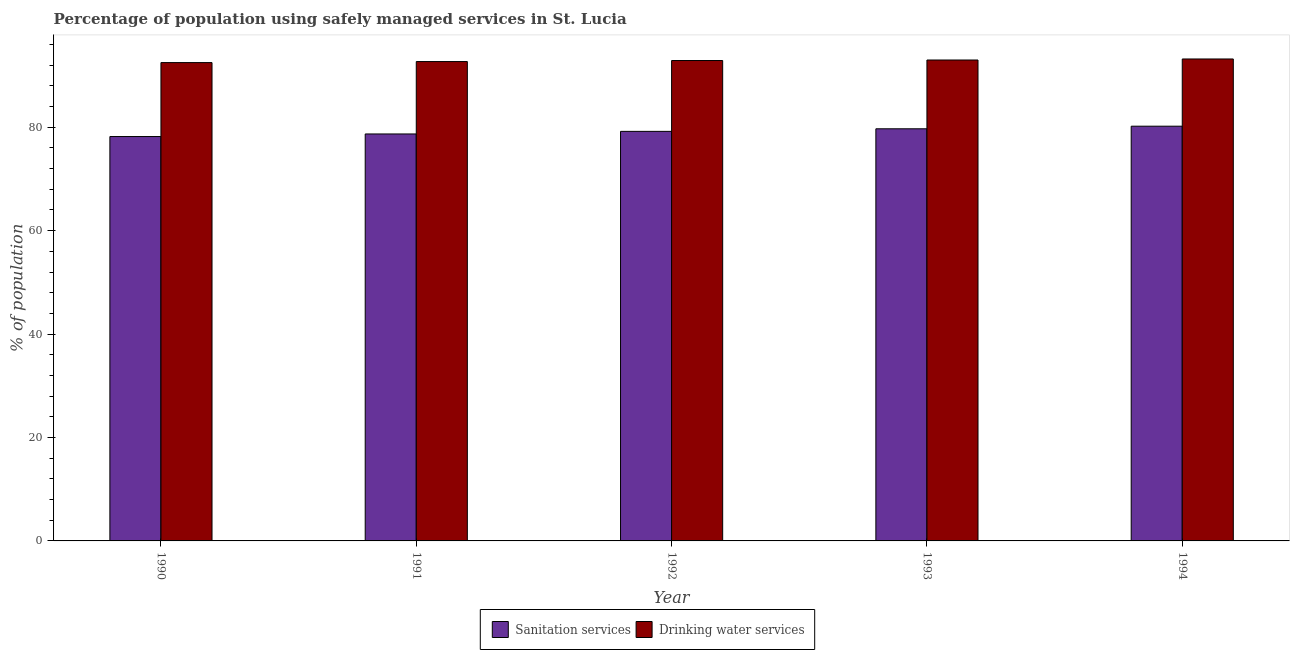Are the number of bars on each tick of the X-axis equal?
Your response must be concise. Yes. What is the label of the 1st group of bars from the left?
Offer a terse response. 1990. What is the percentage of population who used drinking water services in 1992?
Your answer should be very brief. 92.9. Across all years, what is the maximum percentage of population who used drinking water services?
Offer a terse response. 93.2. Across all years, what is the minimum percentage of population who used sanitation services?
Your answer should be very brief. 78.2. In which year was the percentage of population who used drinking water services maximum?
Give a very brief answer. 1994. In which year was the percentage of population who used drinking water services minimum?
Provide a short and direct response. 1990. What is the total percentage of population who used sanitation services in the graph?
Your answer should be very brief. 396. What is the difference between the percentage of population who used drinking water services in 1990 and that in 1994?
Offer a terse response. -0.7. What is the average percentage of population who used sanitation services per year?
Your answer should be very brief. 79.2. In how many years, is the percentage of population who used drinking water services greater than 52 %?
Your answer should be compact. 5. What is the ratio of the percentage of population who used drinking water services in 1990 to that in 1992?
Your answer should be very brief. 1. Is the percentage of population who used drinking water services in 1990 less than that in 1993?
Give a very brief answer. Yes. What is the difference between the highest and the second highest percentage of population who used drinking water services?
Provide a succinct answer. 0.2. What does the 2nd bar from the left in 1993 represents?
Your response must be concise. Drinking water services. What does the 2nd bar from the right in 1992 represents?
Your response must be concise. Sanitation services. Are all the bars in the graph horizontal?
Provide a short and direct response. No. How many years are there in the graph?
Offer a terse response. 5. What is the difference between two consecutive major ticks on the Y-axis?
Keep it short and to the point. 20. Where does the legend appear in the graph?
Ensure brevity in your answer.  Bottom center. How are the legend labels stacked?
Offer a very short reply. Horizontal. What is the title of the graph?
Your answer should be very brief. Percentage of population using safely managed services in St. Lucia. What is the label or title of the X-axis?
Provide a short and direct response. Year. What is the label or title of the Y-axis?
Make the answer very short. % of population. What is the % of population in Sanitation services in 1990?
Your response must be concise. 78.2. What is the % of population in Drinking water services in 1990?
Your answer should be compact. 92.5. What is the % of population in Sanitation services in 1991?
Provide a succinct answer. 78.7. What is the % of population of Drinking water services in 1991?
Offer a very short reply. 92.7. What is the % of population in Sanitation services in 1992?
Offer a terse response. 79.2. What is the % of population of Drinking water services in 1992?
Make the answer very short. 92.9. What is the % of population of Sanitation services in 1993?
Your answer should be very brief. 79.7. What is the % of population of Drinking water services in 1993?
Keep it short and to the point. 93. What is the % of population in Sanitation services in 1994?
Keep it short and to the point. 80.2. What is the % of population in Drinking water services in 1994?
Offer a terse response. 93.2. Across all years, what is the maximum % of population in Sanitation services?
Offer a very short reply. 80.2. Across all years, what is the maximum % of population in Drinking water services?
Your response must be concise. 93.2. Across all years, what is the minimum % of population of Sanitation services?
Provide a short and direct response. 78.2. Across all years, what is the minimum % of population in Drinking water services?
Provide a short and direct response. 92.5. What is the total % of population of Sanitation services in the graph?
Offer a terse response. 396. What is the total % of population in Drinking water services in the graph?
Keep it short and to the point. 464.3. What is the difference between the % of population of Drinking water services in 1990 and that in 1991?
Provide a short and direct response. -0.2. What is the difference between the % of population in Sanitation services in 1990 and that in 1992?
Your answer should be compact. -1. What is the difference between the % of population in Drinking water services in 1990 and that in 1993?
Your response must be concise. -0.5. What is the difference between the % of population in Sanitation services in 1990 and that in 1994?
Ensure brevity in your answer.  -2. What is the difference between the % of population in Drinking water services in 1991 and that in 1992?
Your answer should be very brief. -0.2. What is the difference between the % of population in Sanitation services in 1991 and that in 1993?
Your answer should be compact. -1. What is the difference between the % of population in Drinking water services in 1991 and that in 1994?
Keep it short and to the point. -0.5. What is the difference between the % of population of Sanitation services in 1992 and that in 1993?
Provide a short and direct response. -0.5. What is the difference between the % of population in Drinking water services in 1992 and that in 1993?
Provide a succinct answer. -0.1. What is the difference between the % of population in Drinking water services in 1992 and that in 1994?
Make the answer very short. -0.3. What is the difference between the % of population of Sanitation services in 1993 and that in 1994?
Your answer should be very brief. -0.5. What is the difference between the % of population in Sanitation services in 1990 and the % of population in Drinking water services in 1991?
Make the answer very short. -14.5. What is the difference between the % of population in Sanitation services in 1990 and the % of population in Drinking water services in 1992?
Your response must be concise. -14.7. What is the difference between the % of population in Sanitation services in 1990 and the % of population in Drinking water services in 1993?
Make the answer very short. -14.8. What is the difference between the % of population of Sanitation services in 1990 and the % of population of Drinking water services in 1994?
Provide a succinct answer. -15. What is the difference between the % of population in Sanitation services in 1991 and the % of population in Drinking water services in 1992?
Your response must be concise. -14.2. What is the difference between the % of population of Sanitation services in 1991 and the % of population of Drinking water services in 1993?
Make the answer very short. -14.3. What is the difference between the % of population in Sanitation services in 1992 and the % of population in Drinking water services in 1993?
Ensure brevity in your answer.  -13.8. What is the average % of population in Sanitation services per year?
Ensure brevity in your answer.  79.2. What is the average % of population in Drinking water services per year?
Your response must be concise. 92.86. In the year 1990, what is the difference between the % of population of Sanitation services and % of population of Drinking water services?
Ensure brevity in your answer.  -14.3. In the year 1991, what is the difference between the % of population in Sanitation services and % of population in Drinking water services?
Ensure brevity in your answer.  -14. In the year 1992, what is the difference between the % of population in Sanitation services and % of population in Drinking water services?
Offer a terse response. -13.7. In the year 1994, what is the difference between the % of population of Sanitation services and % of population of Drinking water services?
Keep it short and to the point. -13. What is the ratio of the % of population in Sanitation services in 1990 to that in 1992?
Provide a succinct answer. 0.99. What is the ratio of the % of population in Drinking water services in 1990 to that in 1992?
Your answer should be very brief. 1. What is the ratio of the % of population in Sanitation services in 1990 to that in 1993?
Offer a very short reply. 0.98. What is the ratio of the % of population of Drinking water services in 1990 to that in 1993?
Make the answer very short. 0.99. What is the ratio of the % of population of Sanitation services in 1990 to that in 1994?
Provide a succinct answer. 0.98. What is the ratio of the % of population in Drinking water services in 1990 to that in 1994?
Your answer should be very brief. 0.99. What is the ratio of the % of population of Drinking water services in 1991 to that in 1992?
Offer a very short reply. 1. What is the ratio of the % of population in Sanitation services in 1991 to that in 1993?
Provide a short and direct response. 0.99. What is the ratio of the % of population in Drinking water services in 1991 to that in 1993?
Your response must be concise. 1. What is the ratio of the % of population of Sanitation services in 1991 to that in 1994?
Ensure brevity in your answer.  0.98. What is the ratio of the % of population in Drinking water services in 1991 to that in 1994?
Your response must be concise. 0.99. What is the ratio of the % of population of Sanitation services in 1992 to that in 1993?
Offer a terse response. 0.99. What is the ratio of the % of population in Sanitation services in 1992 to that in 1994?
Provide a succinct answer. 0.99. What is the ratio of the % of population in Sanitation services in 1993 to that in 1994?
Offer a terse response. 0.99. What is the difference between the highest and the second highest % of population in Drinking water services?
Give a very brief answer. 0.2. 